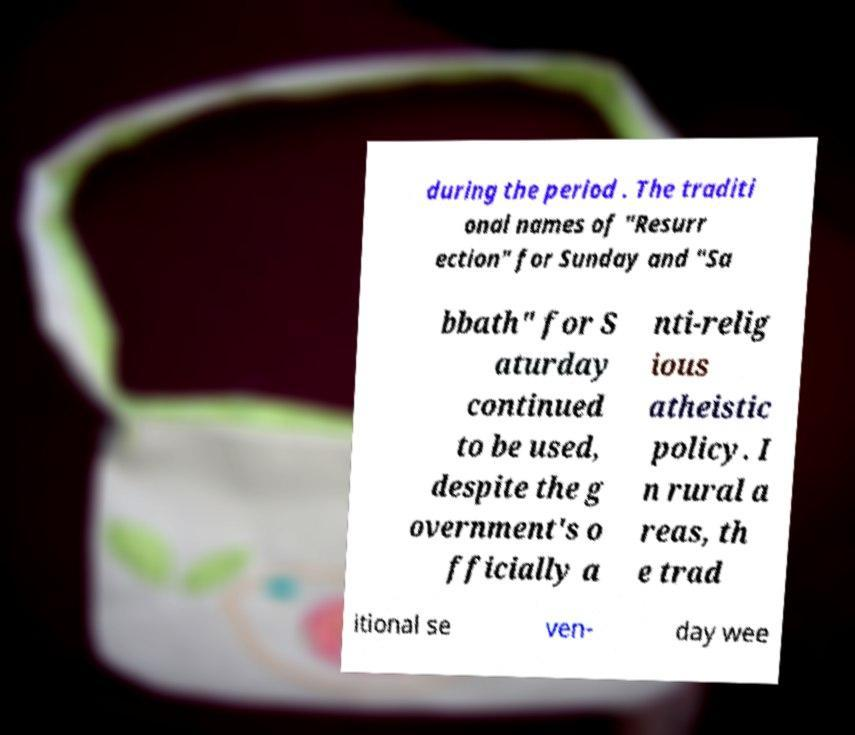Could you assist in decoding the text presented in this image and type it out clearly? during the period . The traditi onal names of "Resurr ection" for Sunday and "Sa bbath" for S aturday continued to be used, despite the g overnment's o fficially a nti-relig ious atheistic policy. I n rural a reas, th e trad itional se ven- day wee 